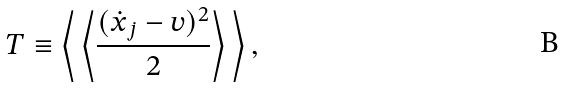Convert formula to latex. <formula><loc_0><loc_0><loc_500><loc_500>T \equiv \left \langle \, \left \langle \frac { ( \dot { x } _ { j } - v ) ^ { 2 } } { 2 } \right \rangle \, \right \rangle ,</formula> 